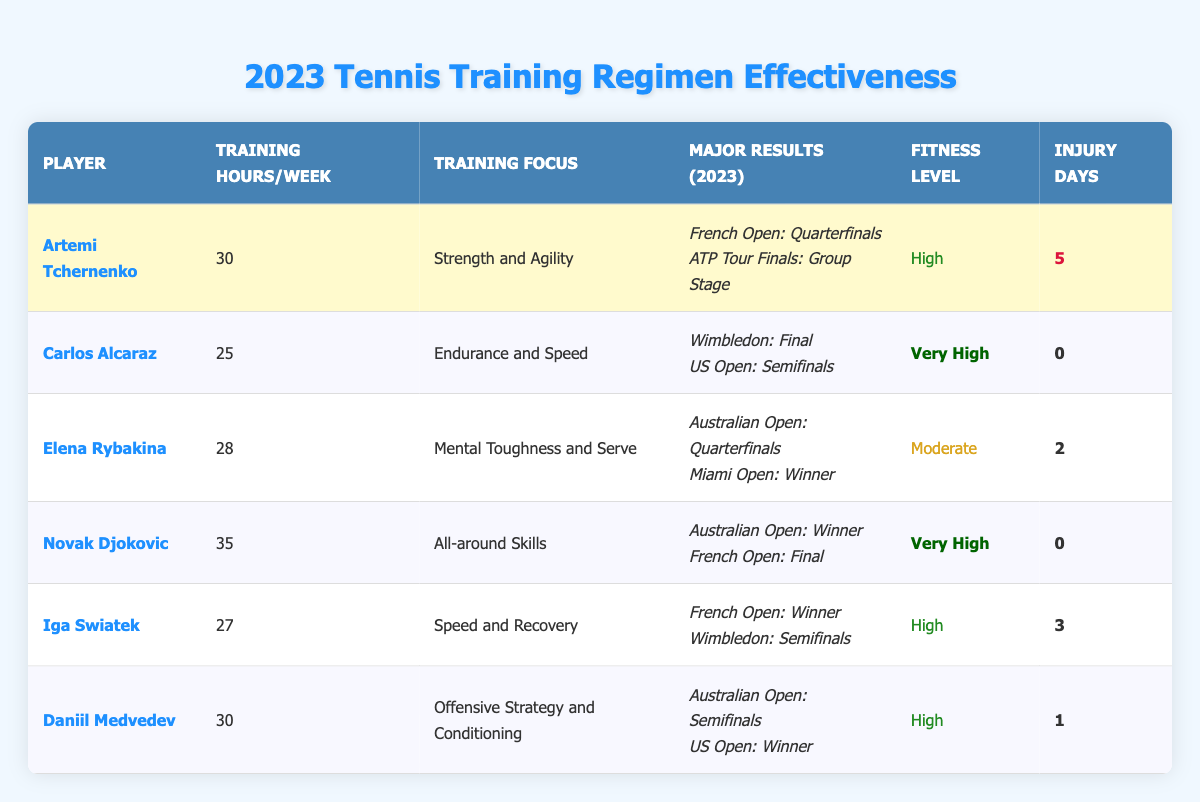What is the training focus of Artemi Tchernenko? Referring to the table, the row for Artemi Tchernenko indicates that his training focus is "Strength and Agility."
Answer: Strength and Agility Which player had the highest training hours per week? By examining the table, Novak Djokovic's training hours per week are 35, which is the highest compared to the other players.
Answer: 35 How many major results did Iga Swiatek achieve? The table lists two major events for Iga Swiatek: "French Open: Winner" and "Wimbledon: Semifinals," indicating that she achieved 2 major results.
Answer: 2 Is it true that Carlos Alcaraz had any injury days in 2023? Looking at the table, it shows that Carlos Alcaraz had 0 injury days, which confirms that he had no injuries.
Answer: No What is the average training hours per week of all players? To find the average, add the training hours of all players (30 + 25 + 28 + 35 + 27 + 30 = 175) and then divide by the number of players (6). The average training hours is 175/6 = approximately 29.17.
Answer: 29.17 Which player had the lowest fitness level? Upon checking the fitness levels, Elena Rybakina is categorized as "Moderate," which is the lowest compared to the others (High and Very High).
Answer: Elena Rybakina What is the combined total of injury days for all players? The injury days can be summed up directly from the table: 5 (Tchernenko) + 0 (Alcaraz) + 2 (Rybakina) + 0 (Djokovic) + 3 (Swiatek) + 1 (Medvedev) gives a total of 11 injury days.
Answer: 11 Who had more training hours per week, Daniil Medvedev or Iga Swiatek? Daniil Medvedev has 30 training hours per week, while Iga Swiatek has 27. Thus, Medvedev has more training hours.
Answer: Daniil Medvedev What event did Novak Djokovic win in 2023? According to the table, Novak Djokovic won the "Australian Open" in 2023.
Answer: Australian Open Which player reached the semifinals in both major events listed? Checking the table, Daniil Medvedev reached the semifinals at the "Australian Open" and was the "Winner" at the "US Open." Both events feature semifinals in the results.
Answer: Daniil Medvedev 